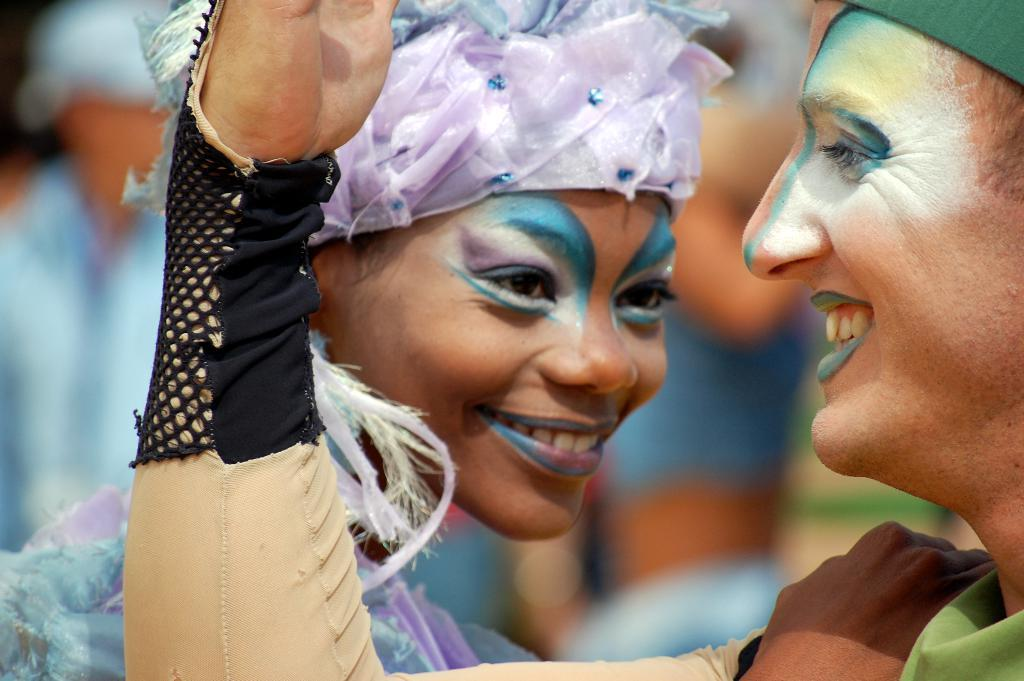How many people are in the foreground of the image? There are two persons in the foreground of the image. What is unique about the appearance of the persons? The faces of the persons are painted. What emotion do the persons seem to be expressing? The persons appear to be smiling. What activity might the persons be engaged in? The persons may be dancing. How would you describe the background of the image? The background of the image is blurred. What type of collar can be seen on the person in the image? There is no collar visible on the persons in the image, as they have painted faces. What source of pleasure can be seen in the image? There is no specific source of pleasure depicted in the image; it features two persons with painted faces who may be dancing. 